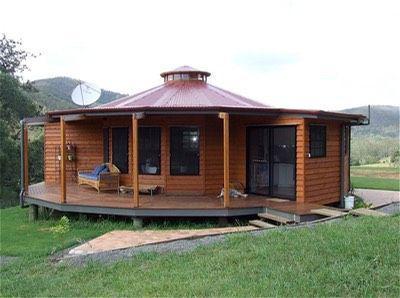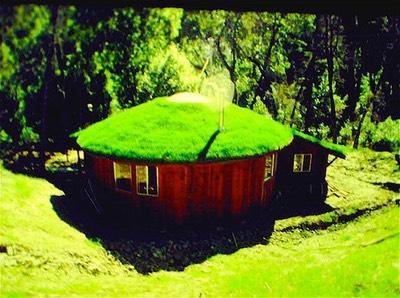The first image is the image on the left, the second image is the image on the right. For the images shown, is this caption "One building has green grass growing on its room." true? Answer yes or no. Yes. The first image is the image on the left, the second image is the image on the right. For the images displayed, is the sentence "The structures in the right image have grass on the roof." factually correct? Answer yes or no. Yes. 